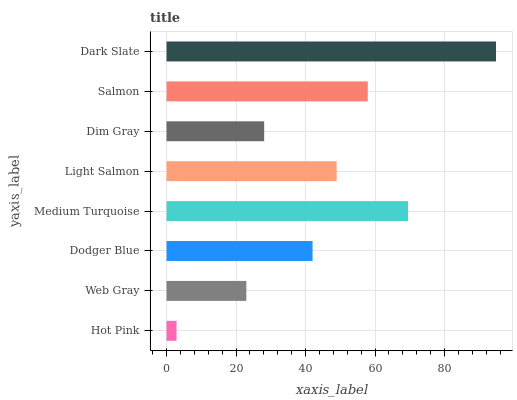Is Hot Pink the minimum?
Answer yes or no. Yes. Is Dark Slate the maximum?
Answer yes or no. Yes. Is Web Gray the minimum?
Answer yes or no. No. Is Web Gray the maximum?
Answer yes or no. No. Is Web Gray greater than Hot Pink?
Answer yes or no. Yes. Is Hot Pink less than Web Gray?
Answer yes or no. Yes. Is Hot Pink greater than Web Gray?
Answer yes or no. No. Is Web Gray less than Hot Pink?
Answer yes or no. No. Is Light Salmon the high median?
Answer yes or no. Yes. Is Dodger Blue the low median?
Answer yes or no. Yes. Is Salmon the high median?
Answer yes or no. No. Is Web Gray the low median?
Answer yes or no. No. 